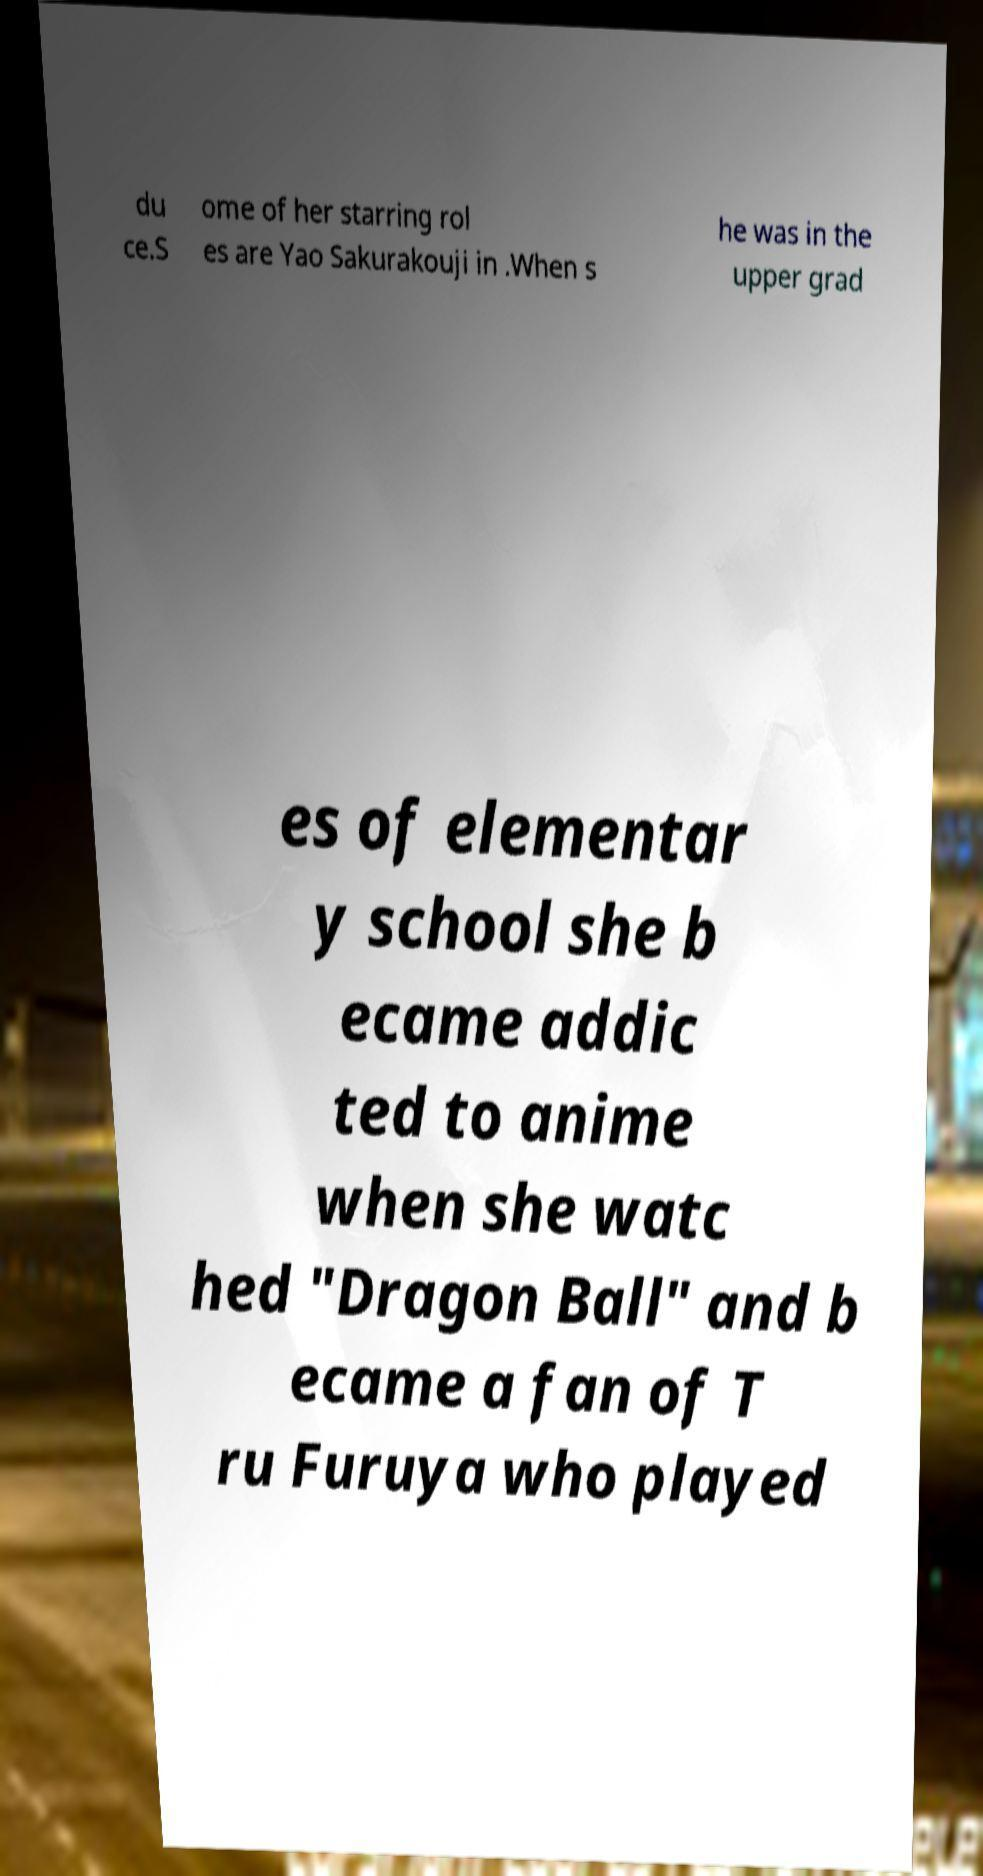There's text embedded in this image that I need extracted. Can you transcribe it verbatim? du ce.S ome of her starring rol es are Yao Sakurakouji in .When s he was in the upper grad es of elementar y school she b ecame addic ted to anime when she watc hed "Dragon Ball" and b ecame a fan of T ru Furuya who played 